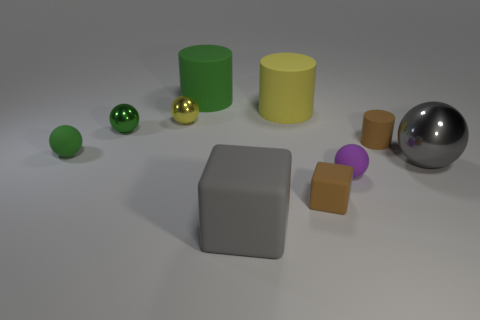There is a metal ball that is on the right side of the big object that is to the left of the big block; what is its size?
Give a very brief answer. Large. There is a gray ball that is the same size as the gray block; what material is it?
Keep it short and to the point. Metal. What number of other things are the same size as the gray matte object?
Give a very brief answer. 3. What number of blocks are either small brown things or big green matte objects?
Keep it short and to the point. 1. There is a small yellow thing behind the brown thing in front of the small purple ball left of the large metal sphere; what is its material?
Offer a terse response. Metal. There is a cube that is the same color as the tiny cylinder; what is its material?
Your answer should be very brief. Rubber. How many small yellow cylinders have the same material as the yellow sphere?
Your answer should be very brief. 0. Do the brown rubber thing on the right side of the purple rubber sphere and the yellow matte cylinder have the same size?
Give a very brief answer. No. What is the color of the small cylinder that is made of the same material as the tiny cube?
Offer a terse response. Brown. There is a tiny brown cube; how many tiny purple matte balls are right of it?
Offer a very short reply. 1. 